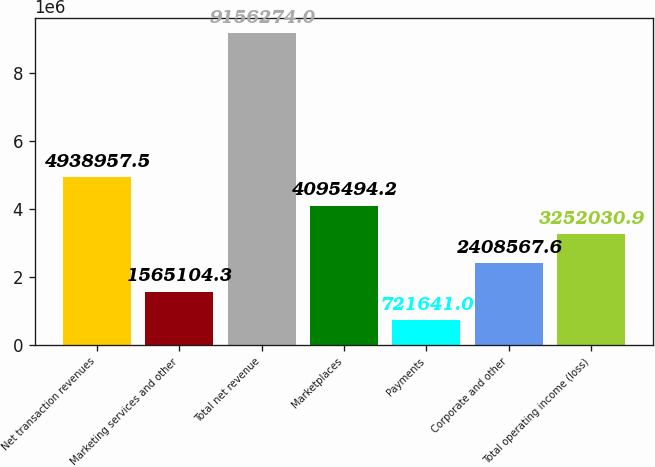Convert chart to OTSL. <chart><loc_0><loc_0><loc_500><loc_500><bar_chart><fcel>Net transaction revenues<fcel>Marketing services and other<fcel>Total net revenue<fcel>Marketplaces<fcel>Payments<fcel>Corporate and other<fcel>Total operating income (loss)<nl><fcel>4.93896e+06<fcel>1.5651e+06<fcel>9.15627e+06<fcel>4.09549e+06<fcel>721641<fcel>2.40857e+06<fcel>3.25203e+06<nl></chart> 